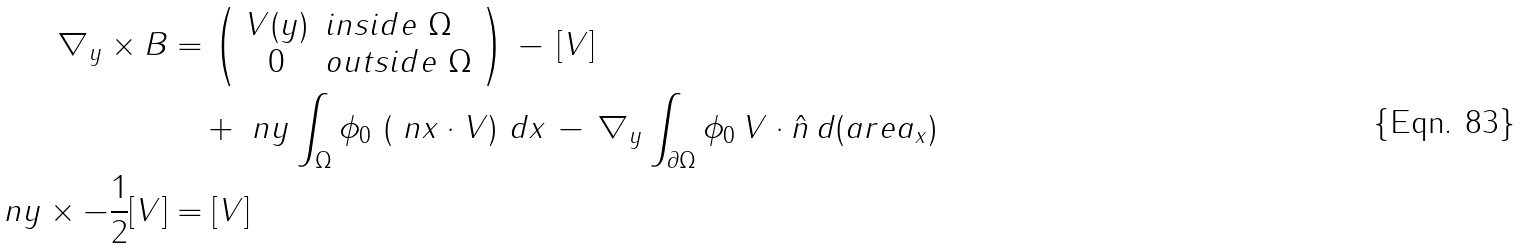<formula> <loc_0><loc_0><loc_500><loc_500>\nabla _ { y } \times B & = \left ( \begin{array} { c l } V ( y ) & i n s i d e \ \Omega \\ 0 & o u t s i d e \ \Omega \end{array} \right ) \, - \, [ V ] \\ & \quad + \ n y \int _ { \Omega } { \phi _ { 0 } \, \left ( \ n x \cdot V \right ) \, d x } \, - \, \nabla _ { y } \int _ { \partial \Omega } { \phi _ { 0 } \, V \cdot \hat { n } \, d ( a r e a _ { x } ) } \\ \ n y \times - \frac { 1 } { 2 } [ V ] & = [ V ]</formula> 